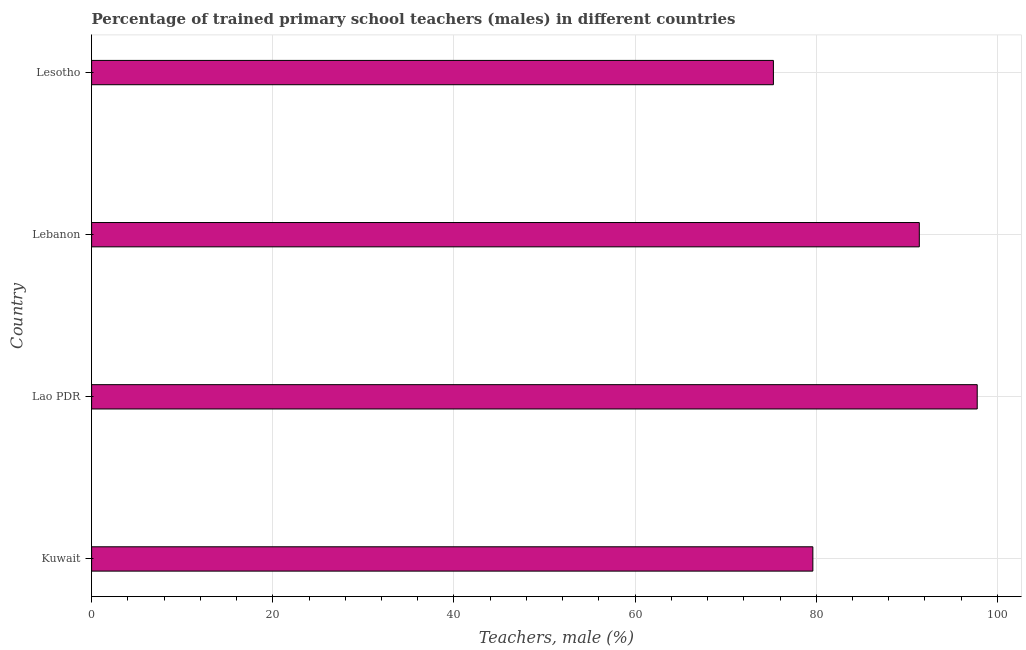What is the title of the graph?
Your response must be concise. Percentage of trained primary school teachers (males) in different countries. What is the label or title of the X-axis?
Keep it short and to the point. Teachers, male (%). What is the percentage of trained male teachers in Lao PDR?
Provide a short and direct response. 97.77. Across all countries, what is the maximum percentage of trained male teachers?
Make the answer very short. 97.77. Across all countries, what is the minimum percentage of trained male teachers?
Offer a terse response. 75.27. In which country was the percentage of trained male teachers maximum?
Ensure brevity in your answer.  Lao PDR. In which country was the percentage of trained male teachers minimum?
Offer a terse response. Lesotho. What is the sum of the percentage of trained male teachers?
Make the answer very short. 344.05. What is the difference between the percentage of trained male teachers in Kuwait and Lao PDR?
Make the answer very short. -18.14. What is the average percentage of trained male teachers per country?
Provide a short and direct response. 86.01. What is the median percentage of trained male teachers?
Your answer should be very brief. 85.5. In how many countries, is the percentage of trained male teachers greater than 92 %?
Your answer should be very brief. 1. What is the ratio of the percentage of trained male teachers in Lao PDR to that in Lebanon?
Provide a succinct answer. 1.07. Is the difference between the percentage of trained male teachers in Kuwait and Lesotho greater than the difference between any two countries?
Provide a short and direct response. No. What is the difference between the highest and the second highest percentage of trained male teachers?
Give a very brief answer. 6.39. What is the difference between the highest and the lowest percentage of trained male teachers?
Your response must be concise. 22.5. How many countries are there in the graph?
Your answer should be very brief. 4. What is the difference between two consecutive major ticks on the X-axis?
Your response must be concise. 20. What is the Teachers, male (%) of Kuwait?
Offer a very short reply. 79.63. What is the Teachers, male (%) in Lao PDR?
Make the answer very short. 97.77. What is the Teachers, male (%) of Lebanon?
Offer a very short reply. 91.38. What is the Teachers, male (%) of Lesotho?
Give a very brief answer. 75.27. What is the difference between the Teachers, male (%) in Kuwait and Lao PDR?
Your answer should be very brief. -18.14. What is the difference between the Teachers, male (%) in Kuwait and Lebanon?
Your response must be concise. -11.75. What is the difference between the Teachers, male (%) in Kuwait and Lesotho?
Ensure brevity in your answer.  4.35. What is the difference between the Teachers, male (%) in Lao PDR and Lebanon?
Your response must be concise. 6.39. What is the difference between the Teachers, male (%) in Lao PDR and Lesotho?
Your answer should be compact. 22.5. What is the difference between the Teachers, male (%) in Lebanon and Lesotho?
Your response must be concise. 16.11. What is the ratio of the Teachers, male (%) in Kuwait to that in Lao PDR?
Your answer should be compact. 0.81. What is the ratio of the Teachers, male (%) in Kuwait to that in Lebanon?
Your answer should be very brief. 0.87. What is the ratio of the Teachers, male (%) in Kuwait to that in Lesotho?
Your answer should be very brief. 1.06. What is the ratio of the Teachers, male (%) in Lao PDR to that in Lebanon?
Provide a short and direct response. 1.07. What is the ratio of the Teachers, male (%) in Lao PDR to that in Lesotho?
Keep it short and to the point. 1.3. What is the ratio of the Teachers, male (%) in Lebanon to that in Lesotho?
Your response must be concise. 1.21. 